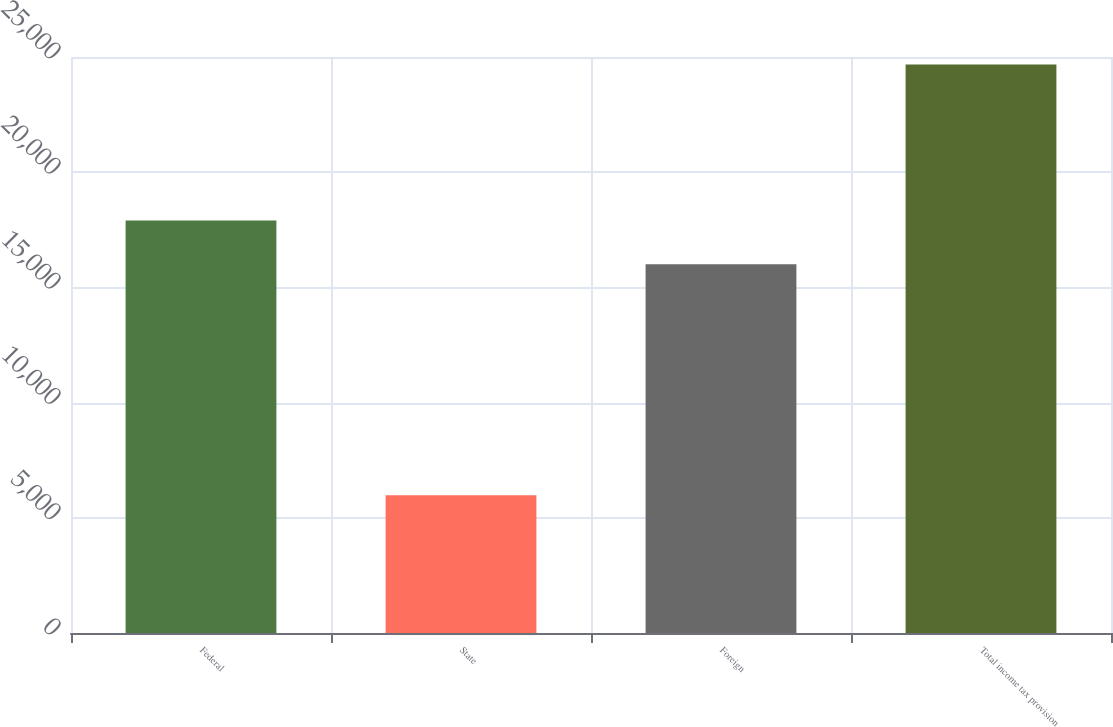Convert chart to OTSL. <chart><loc_0><loc_0><loc_500><loc_500><bar_chart><fcel>Federal<fcel>State<fcel>Foreign<fcel>Total income tax provision<nl><fcel>17900<fcel>5980<fcel>16008<fcel>24678<nl></chart> 